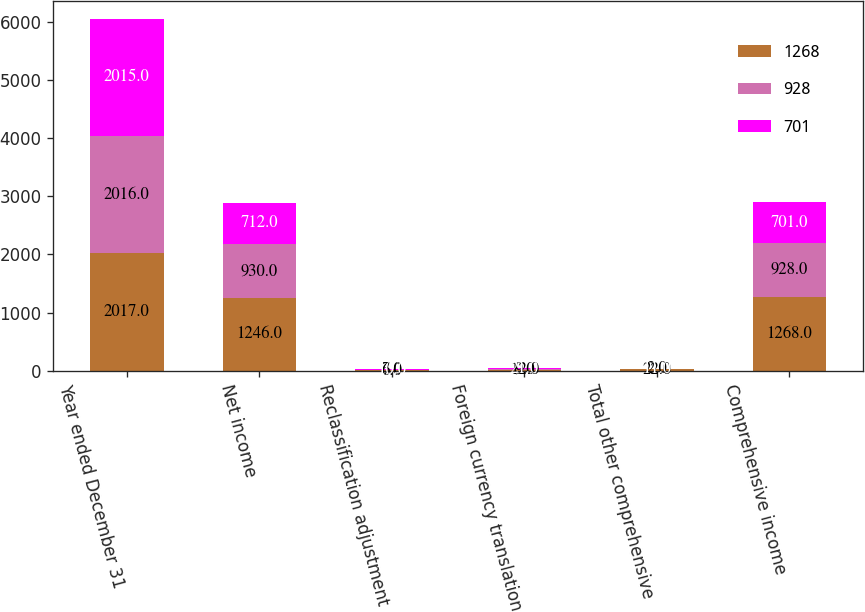<chart> <loc_0><loc_0><loc_500><loc_500><stacked_bar_chart><ecel><fcel>Year ended December 31<fcel>Net income<fcel>Reclassification adjustment<fcel>Foreign currency translation<fcel>Total other comprehensive<fcel>Comprehensive income<nl><fcel>1268<fcel>2017<fcel>1246<fcel>6<fcel>12<fcel>22<fcel>1268<nl><fcel>928<fcel>2016<fcel>930<fcel>7<fcel>9<fcel>2<fcel>928<nl><fcel>701<fcel>2015<fcel>712<fcel>10<fcel>21<fcel>11<fcel>701<nl></chart> 